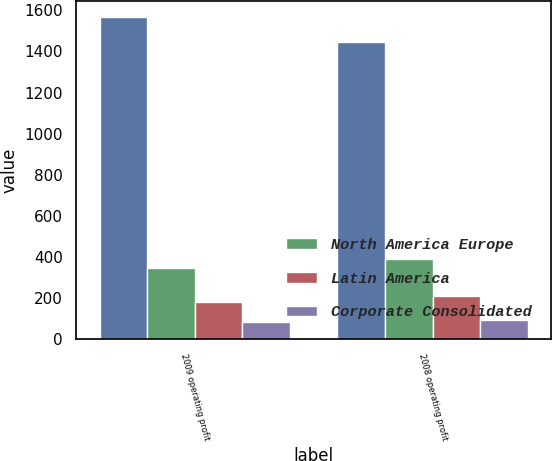<chart> <loc_0><loc_0><loc_500><loc_500><stacked_bar_chart><ecel><fcel>2009 operating profit<fcel>2008 operating profit<nl><fcel>nan<fcel>1569<fcel>1447<nl><fcel>North America Europe<fcel>348<fcel>390<nl><fcel>Latin America<fcel>179<fcel>209<nl><fcel>Corporate Consolidated<fcel>86<fcel>92<nl></chart> 